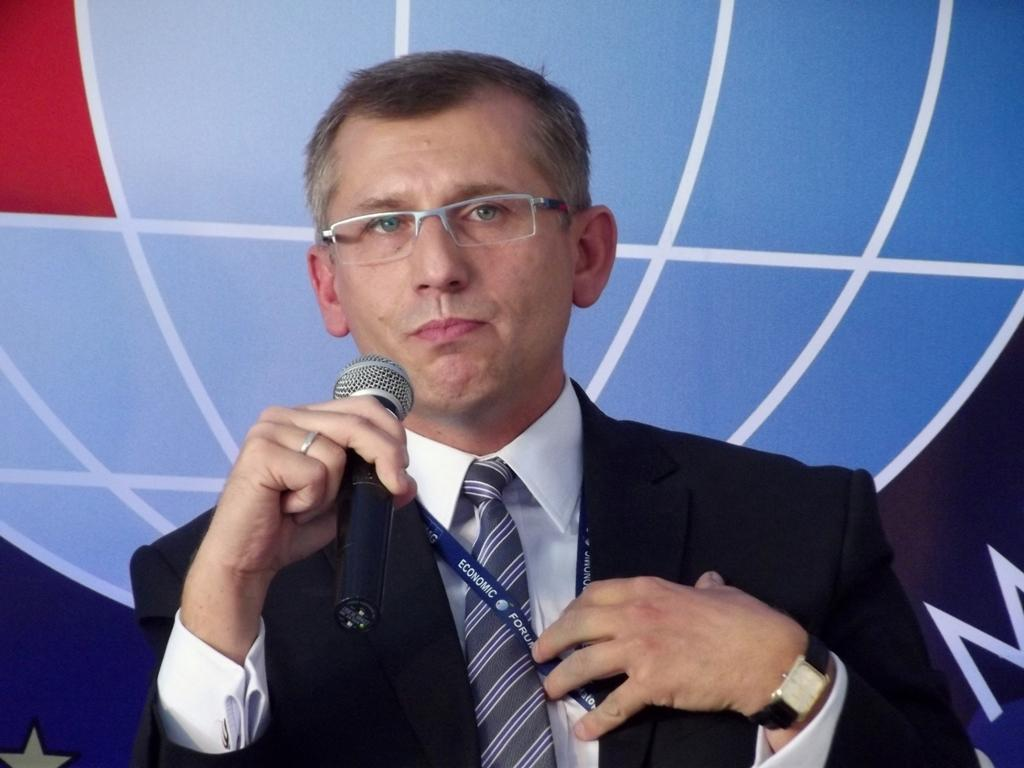Who is present in the image? There is a person in the image. What is the person holding in the image? The person is holding a microphone. What is the person doing in the image? The person is talking. What can be seen in the background of the image? There is a banner visible in the image. What type of pets are visible in the image? There are no pets present in the image. What kind of curtain is hanging behind the person in the image? There is no curtain visible in the image. 